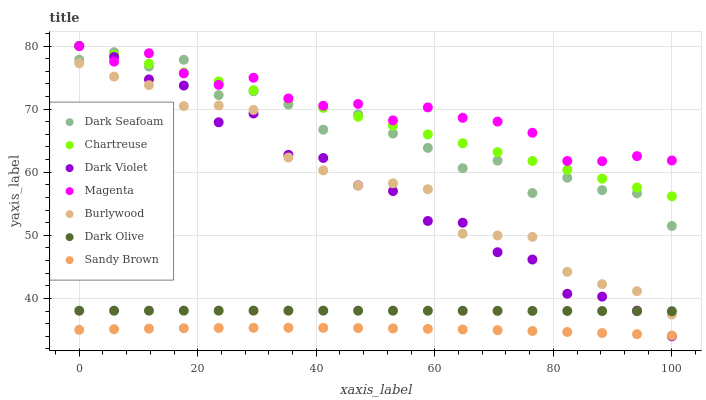Does Sandy Brown have the minimum area under the curve?
Answer yes or no. Yes. Does Magenta have the maximum area under the curve?
Answer yes or no. Yes. Does Dark Olive have the minimum area under the curve?
Answer yes or no. No. Does Dark Olive have the maximum area under the curve?
Answer yes or no. No. Is Chartreuse the smoothest?
Answer yes or no. Yes. Is Dark Violet the roughest?
Answer yes or no. Yes. Is Dark Olive the smoothest?
Answer yes or no. No. Is Dark Olive the roughest?
Answer yes or no. No. Does Dark Violet have the lowest value?
Answer yes or no. Yes. Does Dark Olive have the lowest value?
Answer yes or no. No. Does Magenta have the highest value?
Answer yes or no. Yes. Does Dark Olive have the highest value?
Answer yes or no. No. Is Burlywood less than Dark Seafoam?
Answer yes or no. Yes. Is Dark Seafoam greater than Burlywood?
Answer yes or no. Yes. Does Dark Seafoam intersect Magenta?
Answer yes or no. Yes. Is Dark Seafoam less than Magenta?
Answer yes or no. No. Is Dark Seafoam greater than Magenta?
Answer yes or no. No. Does Burlywood intersect Dark Seafoam?
Answer yes or no. No. 